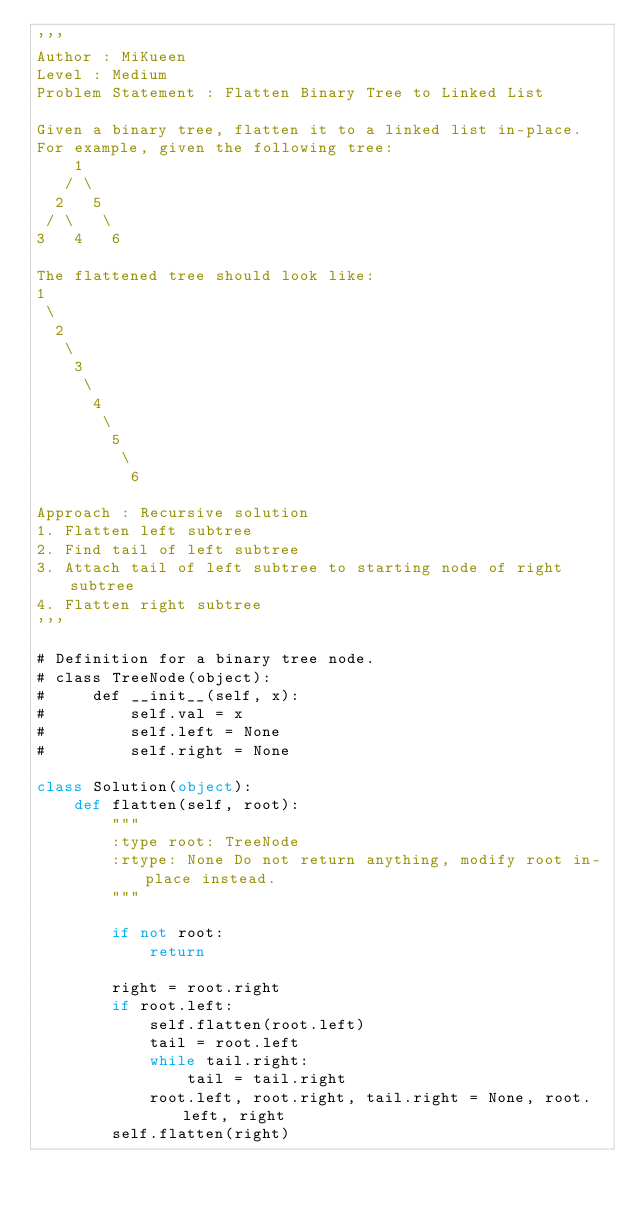Convert code to text. <code><loc_0><loc_0><loc_500><loc_500><_Python_>'''
Author : MiKueen
Level : Medium
Problem Statement : Flatten Binary Tree to Linked List

Given a binary tree, flatten it to a linked list in-place.
For example, given the following tree:
    1
   / \
  2   5
 / \   \
3   4   6

The flattened tree should look like:
1
 \
  2
   \
    3
     \
      4
       \
        5
         \
          6

Approach : Recursive solution
1. Flatten left subtree
2. Find tail of left subtree
3. Attach tail of left subtree to starting node of right subtree
4. Flatten right subtree
'''

# Definition for a binary tree node.
# class TreeNode(object):
#     def __init__(self, x):
#         self.val = x
#         self.left = None
#         self.right = None

class Solution(object):
    def flatten(self, root):
        """
        :type root: TreeNode
        :rtype: None Do not return anything, modify root in-place instead.
        """
        
        if not root:
            return
        
        right = root.right
        if root.left:
            self.flatten(root.left)
            tail = root.left
            while tail.right:
                tail = tail.right
            root.left, root.right, tail.right = None, root.left, right
        self.flatten(right)
                    </code> 